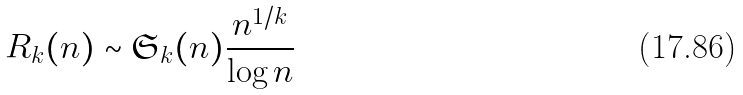Convert formula to latex. <formula><loc_0><loc_0><loc_500><loc_500>R _ { k } ( n ) \sim \mathfrak { S } _ { k } ( n ) \frac { n ^ { 1 / k } } { \log n }</formula> 